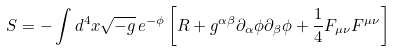Convert formula to latex. <formula><loc_0><loc_0><loc_500><loc_500>S = - \int d ^ { 4 } x \sqrt { - g } \, e ^ { - \phi } \left [ R + g ^ { \alpha \beta } \partial _ { \alpha } \phi \partial _ { \beta } \phi + \frac { 1 } { 4 } F _ { \mu \nu } F ^ { \mu \nu } \right ]</formula> 